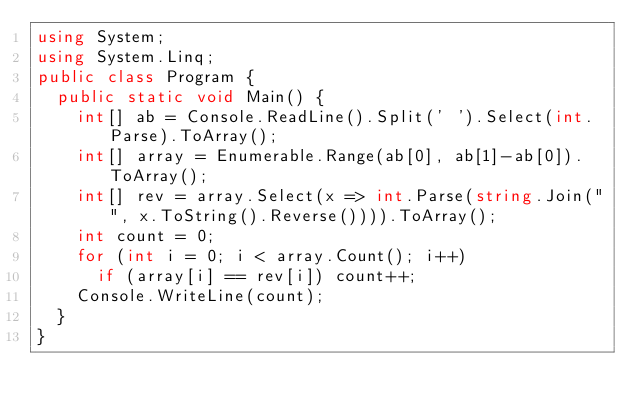Convert code to text. <code><loc_0><loc_0><loc_500><loc_500><_C#_>using System;
using System.Linq;
public class Program {
  public static void Main() {
    int[] ab = Console.ReadLine().Split(' ').Select(int.Parse).ToArray();
    int[] array = Enumerable.Range(ab[0], ab[1]-ab[0]).ToArray();
    int[] rev = array.Select(x => int.Parse(string.Join("", x.ToString().Reverse()))).ToArray();
    int count = 0;
    for (int i = 0; i < array.Count(); i++)
      if (array[i] == rev[i]) count++;
    Console.WriteLine(count);
  }
}
</code> 